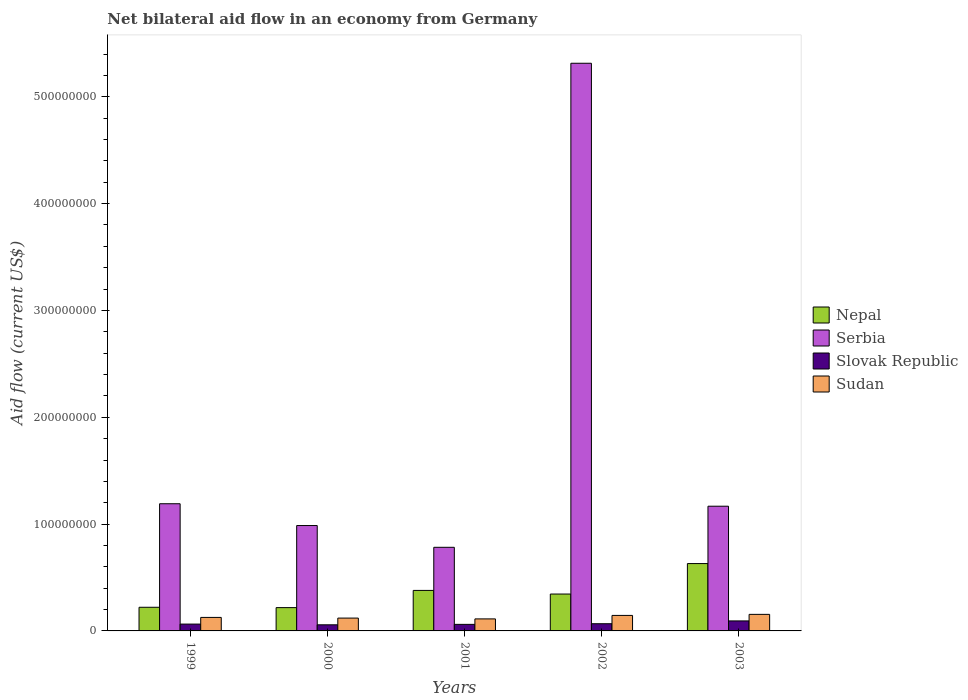How many different coloured bars are there?
Provide a short and direct response. 4. How many groups of bars are there?
Provide a succinct answer. 5. Are the number of bars on each tick of the X-axis equal?
Ensure brevity in your answer.  Yes. How many bars are there on the 1st tick from the right?
Provide a succinct answer. 4. What is the label of the 1st group of bars from the left?
Provide a short and direct response. 1999. In how many cases, is the number of bars for a given year not equal to the number of legend labels?
Give a very brief answer. 0. What is the net bilateral aid flow in Nepal in 2000?
Provide a short and direct response. 2.18e+07. Across all years, what is the maximum net bilateral aid flow in Sudan?
Ensure brevity in your answer.  1.55e+07. Across all years, what is the minimum net bilateral aid flow in Nepal?
Keep it short and to the point. 2.18e+07. In which year was the net bilateral aid flow in Serbia maximum?
Provide a succinct answer. 2002. In which year was the net bilateral aid flow in Slovak Republic minimum?
Provide a short and direct response. 2000. What is the total net bilateral aid flow in Nepal in the graph?
Keep it short and to the point. 1.79e+08. What is the difference between the net bilateral aid flow in Sudan in 1999 and that in 2003?
Keep it short and to the point. -2.85e+06. What is the difference between the net bilateral aid flow in Nepal in 2000 and the net bilateral aid flow in Serbia in 1999?
Give a very brief answer. -9.72e+07. What is the average net bilateral aid flow in Sudan per year?
Keep it short and to the point. 1.32e+07. In the year 1999, what is the difference between the net bilateral aid flow in Serbia and net bilateral aid flow in Sudan?
Give a very brief answer. 1.06e+08. In how many years, is the net bilateral aid flow in Serbia greater than 260000000 US$?
Provide a short and direct response. 1. What is the ratio of the net bilateral aid flow in Nepal in 1999 to that in 2000?
Keep it short and to the point. 1.02. What is the difference between the highest and the second highest net bilateral aid flow in Serbia?
Provide a succinct answer. 4.12e+08. What is the difference between the highest and the lowest net bilateral aid flow in Nepal?
Offer a very short reply. 4.12e+07. In how many years, is the net bilateral aid flow in Serbia greater than the average net bilateral aid flow in Serbia taken over all years?
Offer a terse response. 1. Is the sum of the net bilateral aid flow in Nepal in 2000 and 2001 greater than the maximum net bilateral aid flow in Serbia across all years?
Offer a terse response. No. Is it the case that in every year, the sum of the net bilateral aid flow in Serbia and net bilateral aid flow in Slovak Republic is greater than the sum of net bilateral aid flow in Sudan and net bilateral aid flow in Nepal?
Make the answer very short. Yes. What does the 1st bar from the left in 2001 represents?
Offer a terse response. Nepal. What does the 2nd bar from the right in 2001 represents?
Give a very brief answer. Slovak Republic. Are all the bars in the graph horizontal?
Keep it short and to the point. No. How many years are there in the graph?
Your answer should be compact. 5. What is the difference between two consecutive major ticks on the Y-axis?
Ensure brevity in your answer.  1.00e+08. Are the values on the major ticks of Y-axis written in scientific E-notation?
Your answer should be compact. No. Does the graph contain any zero values?
Your answer should be very brief. No. Does the graph contain grids?
Provide a succinct answer. No. What is the title of the graph?
Offer a very short reply. Net bilateral aid flow in an economy from Germany. Does "Cayman Islands" appear as one of the legend labels in the graph?
Ensure brevity in your answer.  No. What is the label or title of the X-axis?
Provide a short and direct response. Years. What is the Aid flow (current US$) of Nepal in 1999?
Your answer should be compact. 2.21e+07. What is the Aid flow (current US$) in Serbia in 1999?
Offer a terse response. 1.19e+08. What is the Aid flow (current US$) in Slovak Republic in 1999?
Provide a short and direct response. 6.40e+06. What is the Aid flow (current US$) of Sudan in 1999?
Give a very brief answer. 1.26e+07. What is the Aid flow (current US$) of Nepal in 2000?
Offer a very short reply. 2.18e+07. What is the Aid flow (current US$) of Serbia in 2000?
Your answer should be compact. 9.86e+07. What is the Aid flow (current US$) in Slovak Republic in 2000?
Provide a succinct answer. 5.72e+06. What is the Aid flow (current US$) in Sudan in 2000?
Provide a short and direct response. 1.20e+07. What is the Aid flow (current US$) in Nepal in 2001?
Offer a terse response. 3.79e+07. What is the Aid flow (current US$) in Serbia in 2001?
Your answer should be compact. 7.83e+07. What is the Aid flow (current US$) in Slovak Republic in 2001?
Your answer should be compact. 6.14e+06. What is the Aid flow (current US$) in Sudan in 2001?
Your answer should be compact. 1.13e+07. What is the Aid flow (current US$) of Nepal in 2002?
Your answer should be compact. 3.45e+07. What is the Aid flow (current US$) of Serbia in 2002?
Make the answer very short. 5.31e+08. What is the Aid flow (current US$) in Slovak Republic in 2002?
Offer a very short reply. 6.73e+06. What is the Aid flow (current US$) in Sudan in 2002?
Offer a very short reply. 1.45e+07. What is the Aid flow (current US$) of Nepal in 2003?
Your response must be concise. 6.30e+07. What is the Aid flow (current US$) in Serbia in 2003?
Keep it short and to the point. 1.17e+08. What is the Aid flow (current US$) in Slovak Republic in 2003?
Ensure brevity in your answer.  9.37e+06. What is the Aid flow (current US$) in Sudan in 2003?
Provide a succinct answer. 1.55e+07. Across all years, what is the maximum Aid flow (current US$) in Nepal?
Provide a short and direct response. 6.30e+07. Across all years, what is the maximum Aid flow (current US$) in Serbia?
Your response must be concise. 5.31e+08. Across all years, what is the maximum Aid flow (current US$) in Slovak Republic?
Make the answer very short. 9.37e+06. Across all years, what is the maximum Aid flow (current US$) of Sudan?
Your answer should be compact. 1.55e+07. Across all years, what is the minimum Aid flow (current US$) of Nepal?
Your answer should be very brief. 2.18e+07. Across all years, what is the minimum Aid flow (current US$) of Serbia?
Your answer should be compact. 7.83e+07. Across all years, what is the minimum Aid flow (current US$) of Slovak Republic?
Your answer should be very brief. 5.72e+06. Across all years, what is the minimum Aid flow (current US$) of Sudan?
Offer a very short reply. 1.13e+07. What is the total Aid flow (current US$) in Nepal in the graph?
Give a very brief answer. 1.79e+08. What is the total Aid flow (current US$) of Serbia in the graph?
Provide a succinct answer. 9.44e+08. What is the total Aid flow (current US$) in Slovak Republic in the graph?
Your answer should be very brief. 3.44e+07. What is the total Aid flow (current US$) in Sudan in the graph?
Provide a short and direct response. 6.60e+07. What is the difference between the Aid flow (current US$) in Serbia in 1999 and that in 2000?
Offer a terse response. 2.04e+07. What is the difference between the Aid flow (current US$) in Slovak Republic in 1999 and that in 2000?
Make the answer very short. 6.80e+05. What is the difference between the Aid flow (current US$) in Sudan in 1999 and that in 2000?
Your response must be concise. 6.30e+05. What is the difference between the Aid flow (current US$) of Nepal in 1999 and that in 2001?
Keep it short and to the point. -1.58e+07. What is the difference between the Aid flow (current US$) in Serbia in 1999 and that in 2001?
Offer a terse response. 4.08e+07. What is the difference between the Aid flow (current US$) of Sudan in 1999 and that in 2001?
Provide a short and direct response. 1.39e+06. What is the difference between the Aid flow (current US$) in Nepal in 1999 and that in 2002?
Ensure brevity in your answer.  -1.24e+07. What is the difference between the Aid flow (current US$) of Serbia in 1999 and that in 2002?
Make the answer very short. -4.12e+08. What is the difference between the Aid flow (current US$) in Slovak Republic in 1999 and that in 2002?
Offer a terse response. -3.30e+05. What is the difference between the Aid flow (current US$) in Sudan in 1999 and that in 2002?
Provide a short and direct response. -1.87e+06. What is the difference between the Aid flow (current US$) of Nepal in 1999 and that in 2003?
Keep it short and to the point. -4.09e+07. What is the difference between the Aid flow (current US$) of Serbia in 1999 and that in 2003?
Keep it short and to the point. 2.30e+06. What is the difference between the Aid flow (current US$) in Slovak Republic in 1999 and that in 2003?
Keep it short and to the point. -2.97e+06. What is the difference between the Aid flow (current US$) in Sudan in 1999 and that in 2003?
Offer a very short reply. -2.85e+06. What is the difference between the Aid flow (current US$) of Nepal in 2000 and that in 2001?
Give a very brief answer. -1.61e+07. What is the difference between the Aid flow (current US$) in Serbia in 2000 and that in 2001?
Provide a succinct answer. 2.04e+07. What is the difference between the Aid flow (current US$) of Slovak Republic in 2000 and that in 2001?
Provide a succinct answer. -4.20e+05. What is the difference between the Aid flow (current US$) of Sudan in 2000 and that in 2001?
Provide a short and direct response. 7.60e+05. What is the difference between the Aid flow (current US$) in Nepal in 2000 and that in 2002?
Make the answer very short. -1.27e+07. What is the difference between the Aid flow (current US$) in Serbia in 2000 and that in 2002?
Provide a short and direct response. -4.33e+08. What is the difference between the Aid flow (current US$) of Slovak Republic in 2000 and that in 2002?
Provide a succinct answer. -1.01e+06. What is the difference between the Aid flow (current US$) of Sudan in 2000 and that in 2002?
Keep it short and to the point. -2.50e+06. What is the difference between the Aid flow (current US$) of Nepal in 2000 and that in 2003?
Your answer should be very brief. -4.12e+07. What is the difference between the Aid flow (current US$) of Serbia in 2000 and that in 2003?
Offer a terse response. -1.81e+07. What is the difference between the Aid flow (current US$) in Slovak Republic in 2000 and that in 2003?
Give a very brief answer. -3.65e+06. What is the difference between the Aid flow (current US$) of Sudan in 2000 and that in 2003?
Provide a short and direct response. -3.48e+06. What is the difference between the Aid flow (current US$) of Nepal in 2001 and that in 2002?
Your answer should be compact. 3.40e+06. What is the difference between the Aid flow (current US$) of Serbia in 2001 and that in 2002?
Make the answer very short. -4.53e+08. What is the difference between the Aid flow (current US$) of Slovak Republic in 2001 and that in 2002?
Make the answer very short. -5.90e+05. What is the difference between the Aid flow (current US$) in Sudan in 2001 and that in 2002?
Offer a terse response. -3.26e+06. What is the difference between the Aid flow (current US$) in Nepal in 2001 and that in 2003?
Offer a terse response. -2.51e+07. What is the difference between the Aid flow (current US$) in Serbia in 2001 and that in 2003?
Your answer should be compact. -3.85e+07. What is the difference between the Aid flow (current US$) of Slovak Republic in 2001 and that in 2003?
Your answer should be compact. -3.23e+06. What is the difference between the Aid flow (current US$) in Sudan in 2001 and that in 2003?
Make the answer very short. -4.24e+06. What is the difference between the Aid flow (current US$) in Nepal in 2002 and that in 2003?
Keep it short and to the point. -2.85e+07. What is the difference between the Aid flow (current US$) in Serbia in 2002 and that in 2003?
Your response must be concise. 4.15e+08. What is the difference between the Aid flow (current US$) of Slovak Republic in 2002 and that in 2003?
Your answer should be compact. -2.64e+06. What is the difference between the Aid flow (current US$) of Sudan in 2002 and that in 2003?
Your answer should be very brief. -9.80e+05. What is the difference between the Aid flow (current US$) in Nepal in 1999 and the Aid flow (current US$) in Serbia in 2000?
Keep it short and to the point. -7.65e+07. What is the difference between the Aid flow (current US$) in Nepal in 1999 and the Aid flow (current US$) in Slovak Republic in 2000?
Offer a very short reply. 1.64e+07. What is the difference between the Aid flow (current US$) in Nepal in 1999 and the Aid flow (current US$) in Sudan in 2000?
Your answer should be compact. 1.01e+07. What is the difference between the Aid flow (current US$) in Serbia in 1999 and the Aid flow (current US$) in Slovak Republic in 2000?
Keep it short and to the point. 1.13e+08. What is the difference between the Aid flow (current US$) in Serbia in 1999 and the Aid flow (current US$) in Sudan in 2000?
Your response must be concise. 1.07e+08. What is the difference between the Aid flow (current US$) of Slovak Republic in 1999 and the Aid flow (current US$) of Sudan in 2000?
Give a very brief answer. -5.62e+06. What is the difference between the Aid flow (current US$) of Nepal in 1999 and the Aid flow (current US$) of Serbia in 2001?
Keep it short and to the point. -5.61e+07. What is the difference between the Aid flow (current US$) in Nepal in 1999 and the Aid flow (current US$) in Slovak Republic in 2001?
Provide a succinct answer. 1.60e+07. What is the difference between the Aid flow (current US$) in Nepal in 1999 and the Aid flow (current US$) in Sudan in 2001?
Keep it short and to the point. 1.09e+07. What is the difference between the Aid flow (current US$) in Serbia in 1999 and the Aid flow (current US$) in Slovak Republic in 2001?
Offer a terse response. 1.13e+08. What is the difference between the Aid flow (current US$) in Serbia in 1999 and the Aid flow (current US$) in Sudan in 2001?
Make the answer very short. 1.08e+08. What is the difference between the Aid flow (current US$) in Slovak Republic in 1999 and the Aid flow (current US$) in Sudan in 2001?
Your answer should be very brief. -4.86e+06. What is the difference between the Aid flow (current US$) in Nepal in 1999 and the Aid flow (current US$) in Serbia in 2002?
Your answer should be compact. -5.09e+08. What is the difference between the Aid flow (current US$) of Nepal in 1999 and the Aid flow (current US$) of Slovak Republic in 2002?
Provide a succinct answer. 1.54e+07. What is the difference between the Aid flow (current US$) of Nepal in 1999 and the Aid flow (current US$) of Sudan in 2002?
Provide a succinct answer. 7.62e+06. What is the difference between the Aid flow (current US$) in Serbia in 1999 and the Aid flow (current US$) in Slovak Republic in 2002?
Make the answer very short. 1.12e+08. What is the difference between the Aid flow (current US$) in Serbia in 1999 and the Aid flow (current US$) in Sudan in 2002?
Your answer should be very brief. 1.05e+08. What is the difference between the Aid flow (current US$) in Slovak Republic in 1999 and the Aid flow (current US$) in Sudan in 2002?
Your answer should be compact. -8.12e+06. What is the difference between the Aid flow (current US$) in Nepal in 1999 and the Aid flow (current US$) in Serbia in 2003?
Provide a succinct answer. -9.46e+07. What is the difference between the Aid flow (current US$) of Nepal in 1999 and the Aid flow (current US$) of Slovak Republic in 2003?
Offer a very short reply. 1.28e+07. What is the difference between the Aid flow (current US$) in Nepal in 1999 and the Aid flow (current US$) in Sudan in 2003?
Provide a succinct answer. 6.64e+06. What is the difference between the Aid flow (current US$) of Serbia in 1999 and the Aid flow (current US$) of Slovak Republic in 2003?
Your response must be concise. 1.10e+08. What is the difference between the Aid flow (current US$) in Serbia in 1999 and the Aid flow (current US$) in Sudan in 2003?
Make the answer very short. 1.04e+08. What is the difference between the Aid flow (current US$) of Slovak Republic in 1999 and the Aid flow (current US$) of Sudan in 2003?
Give a very brief answer. -9.10e+06. What is the difference between the Aid flow (current US$) in Nepal in 2000 and the Aid flow (current US$) in Serbia in 2001?
Make the answer very short. -5.65e+07. What is the difference between the Aid flow (current US$) of Nepal in 2000 and the Aid flow (current US$) of Slovak Republic in 2001?
Keep it short and to the point. 1.57e+07. What is the difference between the Aid flow (current US$) in Nepal in 2000 and the Aid flow (current US$) in Sudan in 2001?
Give a very brief answer. 1.06e+07. What is the difference between the Aid flow (current US$) in Serbia in 2000 and the Aid flow (current US$) in Slovak Republic in 2001?
Your answer should be compact. 9.25e+07. What is the difference between the Aid flow (current US$) of Serbia in 2000 and the Aid flow (current US$) of Sudan in 2001?
Offer a very short reply. 8.74e+07. What is the difference between the Aid flow (current US$) of Slovak Republic in 2000 and the Aid flow (current US$) of Sudan in 2001?
Provide a short and direct response. -5.54e+06. What is the difference between the Aid flow (current US$) of Nepal in 2000 and the Aid flow (current US$) of Serbia in 2002?
Give a very brief answer. -5.10e+08. What is the difference between the Aid flow (current US$) in Nepal in 2000 and the Aid flow (current US$) in Slovak Republic in 2002?
Offer a terse response. 1.51e+07. What is the difference between the Aid flow (current US$) in Nepal in 2000 and the Aid flow (current US$) in Sudan in 2002?
Make the answer very short. 7.29e+06. What is the difference between the Aid flow (current US$) in Serbia in 2000 and the Aid flow (current US$) in Slovak Republic in 2002?
Your answer should be compact. 9.19e+07. What is the difference between the Aid flow (current US$) of Serbia in 2000 and the Aid flow (current US$) of Sudan in 2002?
Ensure brevity in your answer.  8.41e+07. What is the difference between the Aid flow (current US$) in Slovak Republic in 2000 and the Aid flow (current US$) in Sudan in 2002?
Your answer should be very brief. -8.80e+06. What is the difference between the Aid flow (current US$) of Nepal in 2000 and the Aid flow (current US$) of Serbia in 2003?
Provide a short and direct response. -9.49e+07. What is the difference between the Aid flow (current US$) of Nepal in 2000 and the Aid flow (current US$) of Slovak Republic in 2003?
Ensure brevity in your answer.  1.24e+07. What is the difference between the Aid flow (current US$) in Nepal in 2000 and the Aid flow (current US$) in Sudan in 2003?
Your response must be concise. 6.31e+06. What is the difference between the Aid flow (current US$) in Serbia in 2000 and the Aid flow (current US$) in Slovak Republic in 2003?
Offer a very short reply. 8.93e+07. What is the difference between the Aid flow (current US$) in Serbia in 2000 and the Aid flow (current US$) in Sudan in 2003?
Your answer should be very brief. 8.32e+07. What is the difference between the Aid flow (current US$) in Slovak Republic in 2000 and the Aid flow (current US$) in Sudan in 2003?
Provide a succinct answer. -9.78e+06. What is the difference between the Aid flow (current US$) of Nepal in 2001 and the Aid flow (current US$) of Serbia in 2002?
Your answer should be very brief. -4.93e+08. What is the difference between the Aid flow (current US$) of Nepal in 2001 and the Aid flow (current US$) of Slovak Republic in 2002?
Offer a very short reply. 3.12e+07. What is the difference between the Aid flow (current US$) of Nepal in 2001 and the Aid flow (current US$) of Sudan in 2002?
Offer a very short reply. 2.34e+07. What is the difference between the Aid flow (current US$) of Serbia in 2001 and the Aid flow (current US$) of Slovak Republic in 2002?
Ensure brevity in your answer.  7.16e+07. What is the difference between the Aid flow (current US$) in Serbia in 2001 and the Aid flow (current US$) in Sudan in 2002?
Make the answer very short. 6.38e+07. What is the difference between the Aid flow (current US$) in Slovak Republic in 2001 and the Aid flow (current US$) in Sudan in 2002?
Offer a very short reply. -8.38e+06. What is the difference between the Aid flow (current US$) of Nepal in 2001 and the Aid flow (current US$) of Serbia in 2003?
Your answer should be very brief. -7.88e+07. What is the difference between the Aid flow (current US$) of Nepal in 2001 and the Aid flow (current US$) of Slovak Republic in 2003?
Your answer should be very brief. 2.86e+07. What is the difference between the Aid flow (current US$) of Nepal in 2001 and the Aid flow (current US$) of Sudan in 2003?
Keep it short and to the point. 2.24e+07. What is the difference between the Aid flow (current US$) of Serbia in 2001 and the Aid flow (current US$) of Slovak Republic in 2003?
Offer a terse response. 6.89e+07. What is the difference between the Aid flow (current US$) in Serbia in 2001 and the Aid flow (current US$) in Sudan in 2003?
Offer a very short reply. 6.28e+07. What is the difference between the Aid flow (current US$) in Slovak Republic in 2001 and the Aid flow (current US$) in Sudan in 2003?
Give a very brief answer. -9.36e+06. What is the difference between the Aid flow (current US$) of Nepal in 2002 and the Aid flow (current US$) of Serbia in 2003?
Give a very brief answer. -8.22e+07. What is the difference between the Aid flow (current US$) in Nepal in 2002 and the Aid flow (current US$) in Slovak Republic in 2003?
Offer a terse response. 2.52e+07. What is the difference between the Aid flow (current US$) in Nepal in 2002 and the Aid flow (current US$) in Sudan in 2003?
Your answer should be compact. 1.90e+07. What is the difference between the Aid flow (current US$) of Serbia in 2002 and the Aid flow (current US$) of Slovak Republic in 2003?
Provide a short and direct response. 5.22e+08. What is the difference between the Aid flow (current US$) of Serbia in 2002 and the Aid flow (current US$) of Sudan in 2003?
Provide a short and direct response. 5.16e+08. What is the difference between the Aid flow (current US$) in Slovak Republic in 2002 and the Aid flow (current US$) in Sudan in 2003?
Offer a very short reply. -8.77e+06. What is the average Aid flow (current US$) in Nepal per year?
Offer a very short reply. 3.59e+07. What is the average Aid flow (current US$) of Serbia per year?
Give a very brief answer. 1.89e+08. What is the average Aid flow (current US$) in Slovak Republic per year?
Offer a terse response. 6.87e+06. What is the average Aid flow (current US$) of Sudan per year?
Offer a terse response. 1.32e+07. In the year 1999, what is the difference between the Aid flow (current US$) of Nepal and Aid flow (current US$) of Serbia?
Your answer should be very brief. -9.69e+07. In the year 1999, what is the difference between the Aid flow (current US$) in Nepal and Aid flow (current US$) in Slovak Republic?
Your answer should be compact. 1.57e+07. In the year 1999, what is the difference between the Aid flow (current US$) of Nepal and Aid flow (current US$) of Sudan?
Your answer should be compact. 9.49e+06. In the year 1999, what is the difference between the Aid flow (current US$) of Serbia and Aid flow (current US$) of Slovak Republic?
Offer a very short reply. 1.13e+08. In the year 1999, what is the difference between the Aid flow (current US$) of Serbia and Aid flow (current US$) of Sudan?
Ensure brevity in your answer.  1.06e+08. In the year 1999, what is the difference between the Aid flow (current US$) in Slovak Republic and Aid flow (current US$) in Sudan?
Your answer should be compact. -6.25e+06. In the year 2000, what is the difference between the Aid flow (current US$) of Nepal and Aid flow (current US$) of Serbia?
Give a very brief answer. -7.68e+07. In the year 2000, what is the difference between the Aid flow (current US$) in Nepal and Aid flow (current US$) in Slovak Republic?
Your response must be concise. 1.61e+07. In the year 2000, what is the difference between the Aid flow (current US$) of Nepal and Aid flow (current US$) of Sudan?
Your answer should be compact. 9.79e+06. In the year 2000, what is the difference between the Aid flow (current US$) in Serbia and Aid flow (current US$) in Slovak Republic?
Offer a terse response. 9.29e+07. In the year 2000, what is the difference between the Aid flow (current US$) in Serbia and Aid flow (current US$) in Sudan?
Provide a short and direct response. 8.66e+07. In the year 2000, what is the difference between the Aid flow (current US$) in Slovak Republic and Aid flow (current US$) in Sudan?
Offer a terse response. -6.30e+06. In the year 2001, what is the difference between the Aid flow (current US$) in Nepal and Aid flow (current US$) in Serbia?
Your answer should be very brief. -4.04e+07. In the year 2001, what is the difference between the Aid flow (current US$) in Nepal and Aid flow (current US$) in Slovak Republic?
Provide a short and direct response. 3.18e+07. In the year 2001, what is the difference between the Aid flow (current US$) in Nepal and Aid flow (current US$) in Sudan?
Provide a succinct answer. 2.67e+07. In the year 2001, what is the difference between the Aid flow (current US$) of Serbia and Aid flow (current US$) of Slovak Republic?
Provide a succinct answer. 7.21e+07. In the year 2001, what is the difference between the Aid flow (current US$) of Serbia and Aid flow (current US$) of Sudan?
Make the answer very short. 6.70e+07. In the year 2001, what is the difference between the Aid flow (current US$) of Slovak Republic and Aid flow (current US$) of Sudan?
Your response must be concise. -5.12e+06. In the year 2002, what is the difference between the Aid flow (current US$) in Nepal and Aid flow (current US$) in Serbia?
Your answer should be compact. -4.97e+08. In the year 2002, what is the difference between the Aid flow (current US$) of Nepal and Aid flow (current US$) of Slovak Republic?
Ensure brevity in your answer.  2.78e+07. In the year 2002, what is the difference between the Aid flow (current US$) of Nepal and Aid flow (current US$) of Sudan?
Give a very brief answer. 2.00e+07. In the year 2002, what is the difference between the Aid flow (current US$) in Serbia and Aid flow (current US$) in Slovak Republic?
Provide a short and direct response. 5.25e+08. In the year 2002, what is the difference between the Aid flow (current US$) in Serbia and Aid flow (current US$) in Sudan?
Offer a terse response. 5.17e+08. In the year 2002, what is the difference between the Aid flow (current US$) of Slovak Republic and Aid flow (current US$) of Sudan?
Offer a terse response. -7.79e+06. In the year 2003, what is the difference between the Aid flow (current US$) in Nepal and Aid flow (current US$) in Serbia?
Ensure brevity in your answer.  -5.37e+07. In the year 2003, what is the difference between the Aid flow (current US$) of Nepal and Aid flow (current US$) of Slovak Republic?
Offer a terse response. 5.37e+07. In the year 2003, what is the difference between the Aid flow (current US$) of Nepal and Aid flow (current US$) of Sudan?
Give a very brief answer. 4.76e+07. In the year 2003, what is the difference between the Aid flow (current US$) of Serbia and Aid flow (current US$) of Slovak Republic?
Your answer should be very brief. 1.07e+08. In the year 2003, what is the difference between the Aid flow (current US$) of Serbia and Aid flow (current US$) of Sudan?
Offer a very short reply. 1.01e+08. In the year 2003, what is the difference between the Aid flow (current US$) in Slovak Republic and Aid flow (current US$) in Sudan?
Provide a short and direct response. -6.13e+06. What is the ratio of the Aid flow (current US$) of Nepal in 1999 to that in 2000?
Give a very brief answer. 1.02. What is the ratio of the Aid flow (current US$) of Serbia in 1999 to that in 2000?
Provide a succinct answer. 1.21. What is the ratio of the Aid flow (current US$) of Slovak Republic in 1999 to that in 2000?
Offer a terse response. 1.12. What is the ratio of the Aid flow (current US$) of Sudan in 1999 to that in 2000?
Offer a very short reply. 1.05. What is the ratio of the Aid flow (current US$) in Nepal in 1999 to that in 2001?
Provide a succinct answer. 0.58. What is the ratio of the Aid flow (current US$) in Serbia in 1999 to that in 2001?
Your answer should be compact. 1.52. What is the ratio of the Aid flow (current US$) of Slovak Republic in 1999 to that in 2001?
Ensure brevity in your answer.  1.04. What is the ratio of the Aid flow (current US$) in Sudan in 1999 to that in 2001?
Your answer should be very brief. 1.12. What is the ratio of the Aid flow (current US$) of Nepal in 1999 to that in 2002?
Provide a short and direct response. 0.64. What is the ratio of the Aid flow (current US$) in Serbia in 1999 to that in 2002?
Provide a succinct answer. 0.22. What is the ratio of the Aid flow (current US$) in Slovak Republic in 1999 to that in 2002?
Give a very brief answer. 0.95. What is the ratio of the Aid flow (current US$) in Sudan in 1999 to that in 2002?
Your response must be concise. 0.87. What is the ratio of the Aid flow (current US$) in Nepal in 1999 to that in 2003?
Ensure brevity in your answer.  0.35. What is the ratio of the Aid flow (current US$) in Serbia in 1999 to that in 2003?
Keep it short and to the point. 1.02. What is the ratio of the Aid flow (current US$) of Slovak Republic in 1999 to that in 2003?
Provide a succinct answer. 0.68. What is the ratio of the Aid flow (current US$) in Sudan in 1999 to that in 2003?
Keep it short and to the point. 0.82. What is the ratio of the Aid flow (current US$) of Nepal in 2000 to that in 2001?
Your answer should be very brief. 0.58. What is the ratio of the Aid flow (current US$) in Serbia in 2000 to that in 2001?
Offer a terse response. 1.26. What is the ratio of the Aid flow (current US$) in Slovak Republic in 2000 to that in 2001?
Provide a short and direct response. 0.93. What is the ratio of the Aid flow (current US$) in Sudan in 2000 to that in 2001?
Offer a very short reply. 1.07. What is the ratio of the Aid flow (current US$) in Nepal in 2000 to that in 2002?
Make the answer very short. 0.63. What is the ratio of the Aid flow (current US$) of Serbia in 2000 to that in 2002?
Your response must be concise. 0.19. What is the ratio of the Aid flow (current US$) in Slovak Republic in 2000 to that in 2002?
Offer a terse response. 0.85. What is the ratio of the Aid flow (current US$) in Sudan in 2000 to that in 2002?
Your answer should be very brief. 0.83. What is the ratio of the Aid flow (current US$) of Nepal in 2000 to that in 2003?
Give a very brief answer. 0.35. What is the ratio of the Aid flow (current US$) in Serbia in 2000 to that in 2003?
Provide a short and direct response. 0.84. What is the ratio of the Aid flow (current US$) in Slovak Republic in 2000 to that in 2003?
Make the answer very short. 0.61. What is the ratio of the Aid flow (current US$) in Sudan in 2000 to that in 2003?
Your answer should be compact. 0.78. What is the ratio of the Aid flow (current US$) in Nepal in 2001 to that in 2002?
Provide a succinct answer. 1.1. What is the ratio of the Aid flow (current US$) in Serbia in 2001 to that in 2002?
Make the answer very short. 0.15. What is the ratio of the Aid flow (current US$) of Slovak Republic in 2001 to that in 2002?
Ensure brevity in your answer.  0.91. What is the ratio of the Aid flow (current US$) in Sudan in 2001 to that in 2002?
Keep it short and to the point. 0.78. What is the ratio of the Aid flow (current US$) of Nepal in 2001 to that in 2003?
Offer a terse response. 0.6. What is the ratio of the Aid flow (current US$) in Serbia in 2001 to that in 2003?
Your answer should be compact. 0.67. What is the ratio of the Aid flow (current US$) in Slovak Republic in 2001 to that in 2003?
Your response must be concise. 0.66. What is the ratio of the Aid flow (current US$) of Sudan in 2001 to that in 2003?
Offer a terse response. 0.73. What is the ratio of the Aid flow (current US$) of Nepal in 2002 to that in 2003?
Make the answer very short. 0.55. What is the ratio of the Aid flow (current US$) of Serbia in 2002 to that in 2003?
Your response must be concise. 4.55. What is the ratio of the Aid flow (current US$) of Slovak Republic in 2002 to that in 2003?
Keep it short and to the point. 0.72. What is the ratio of the Aid flow (current US$) in Sudan in 2002 to that in 2003?
Your answer should be compact. 0.94. What is the difference between the highest and the second highest Aid flow (current US$) in Nepal?
Provide a short and direct response. 2.51e+07. What is the difference between the highest and the second highest Aid flow (current US$) of Serbia?
Your answer should be very brief. 4.12e+08. What is the difference between the highest and the second highest Aid flow (current US$) of Slovak Republic?
Make the answer very short. 2.64e+06. What is the difference between the highest and the second highest Aid flow (current US$) of Sudan?
Give a very brief answer. 9.80e+05. What is the difference between the highest and the lowest Aid flow (current US$) of Nepal?
Provide a short and direct response. 4.12e+07. What is the difference between the highest and the lowest Aid flow (current US$) of Serbia?
Your answer should be very brief. 4.53e+08. What is the difference between the highest and the lowest Aid flow (current US$) in Slovak Republic?
Ensure brevity in your answer.  3.65e+06. What is the difference between the highest and the lowest Aid flow (current US$) in Sudan?
Offer a very short reply. 4.24e+06. 